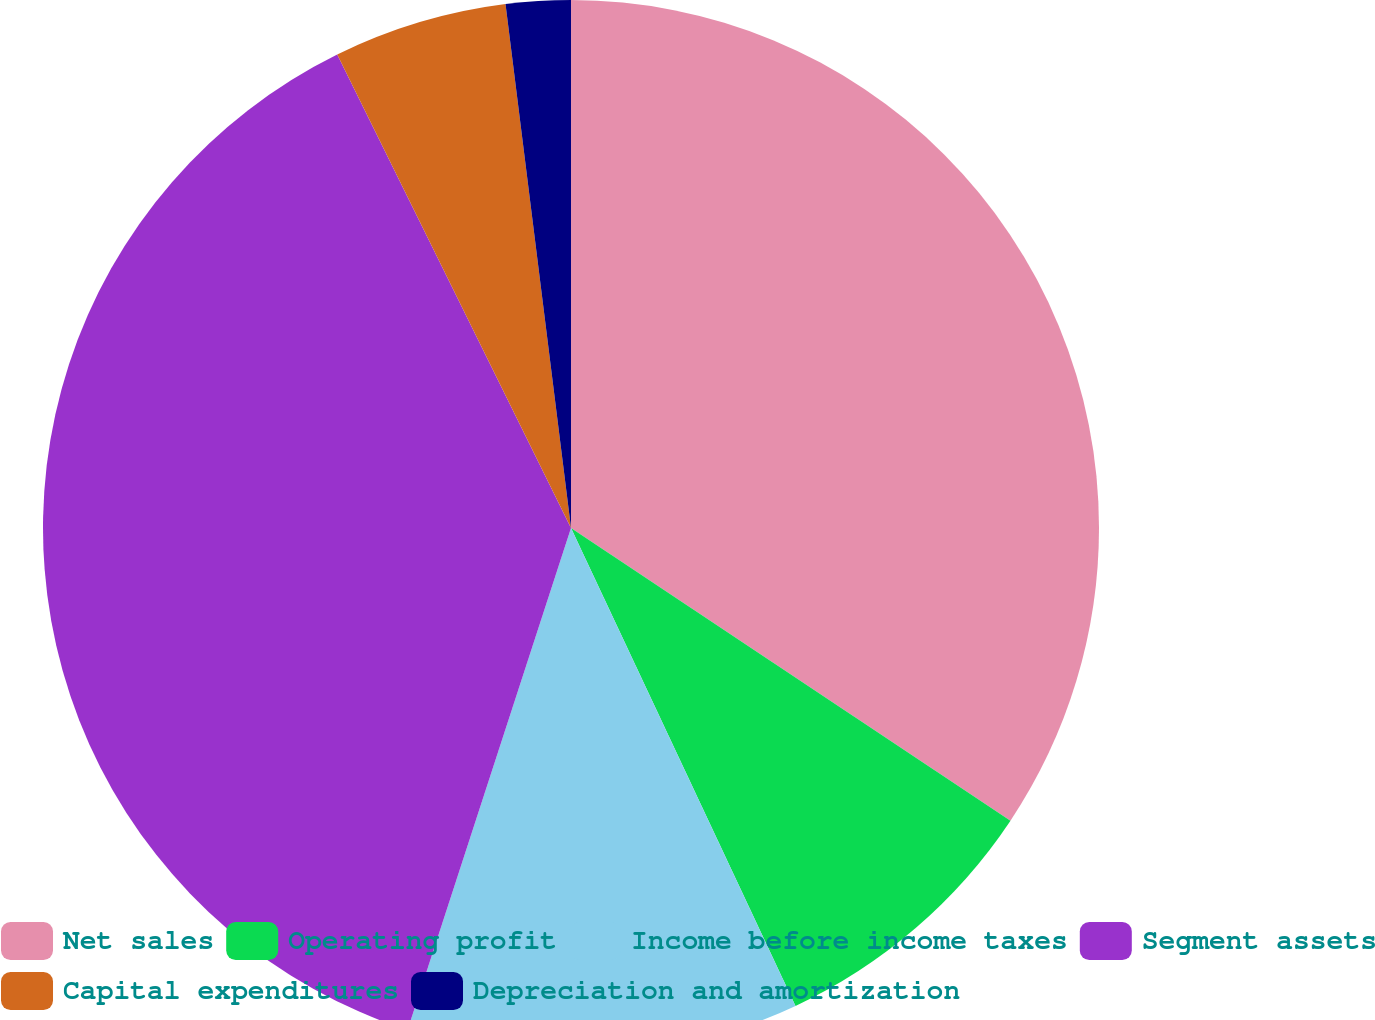Convert chart. <chart><loc_0><loc_0><loc_500><loc_500><pie_chart><fcel>Net sales<fcel>Operating profit<fcel>Income before income taxes<fcel>Segment assets<fcel>Capital expenditures<fcel>Depreciation and amortization<nl><fcel>34.35%<fcel>8.66%<fcel>12.0%<fcel>37.69%<fcel>5.32%<fcel>1.98%<nl></chart> 